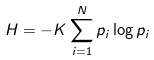Convert formula to latex. <formula><loc_0><loc_0><loc_500><loc_500>H = - K \sum _ { i = 1 } ^ { N } p _ { i } \log { p _ { i } }</formula> 